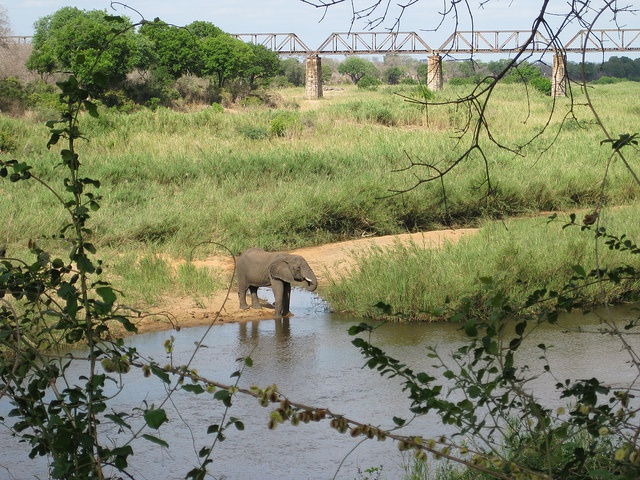Describe the objects in this image and their specific colors. I can see a elephant in lavender, gray, and black tones in this image. 